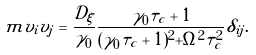<formula> <loc_0><loc_0><loc_500><loc_500>\ m { v _ { i } v _ { j } } = \frac { \mathcal { D } _ { \xi } } { \gamma _ { 0 } } \frac { \gamma _ { 0 } \tau _ { c } + 1 } { ( \gamma _ { 0 } \tau _ { c } + 1 ) ^ { 2 } + \Omega ^ { 2 } \tau _ { c } ^ { 2 } } \delta _ { i j } .</formula> 